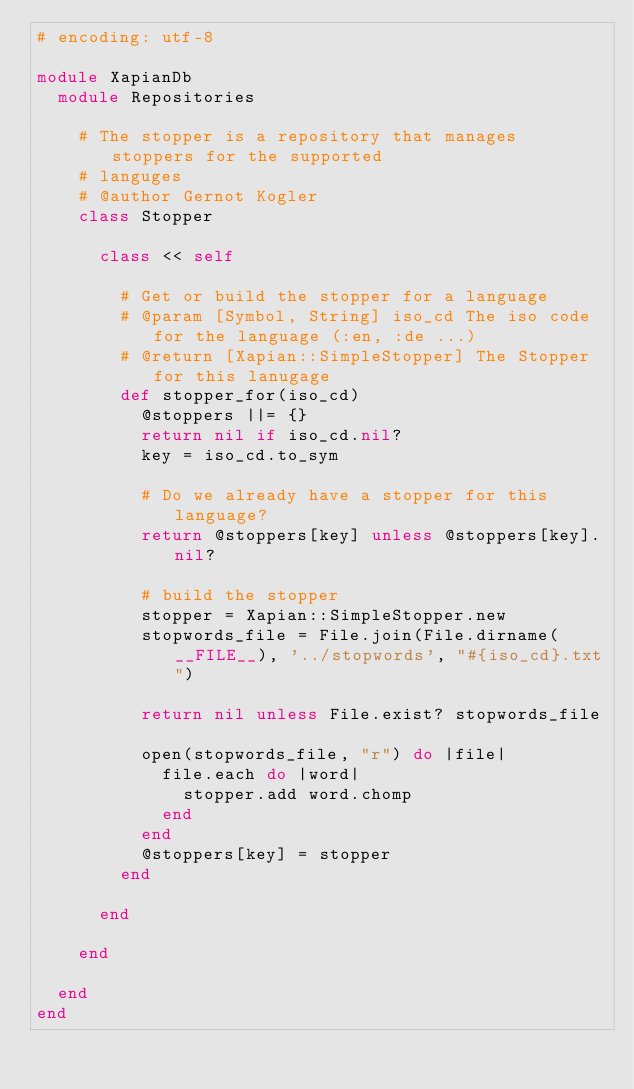<code> <loc_0><loc_0><loc_500><loc_500><_Ruby_># encoding: utf-8

module XapianDb
  module Repositories

    # The stopper is a repository that manages stoppers for the supported
    # languges
    # @author Gernot Kogler
    class Stopper

      class << self

        # Get or build the stopper for a language
        # @param [Symbol, String] iso_cd The iso code for the language (:en, :de ...)
        # @return [Xapian::SimpleStopper] The Stopper for this lanugage
        def stopper_for(iso_cd)
          @stoppers ||= {}
          return nil if iso_cd.nil?
          key = iso_cd.to_sym

          # Do we already have a stopper for this language?
          return @stoppers[key] unless @stoppers[key].nil?

          # build the stopper
          stopper = Xapian::SimpleStopper.new
          stopwords_file = File.join(File.dirname(__FILE__), '../stopwords', "#{iso_cd}.txt")

          return nil unless File.exist? stopwords_file

          open(stopwords_file, "r") do |file|
            file.each do |word|
              stopper.add word.chomp
            end
          end
          @stoppers[key] = stopper
        end

      end

    end

  end
end</code> 